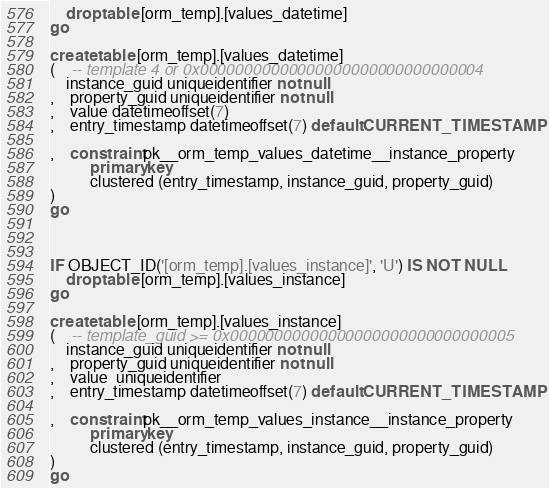Convert code to text. <code><loc_0><loc_0><loc_500><loc_500><_SQL_>	drop table [orm_temp].[values_datetime]
go

create table [orm_temp].[values_datetime]
(	-- template 4 or 0x00000000000000000000000000000004
	instance_guid uniqueidentifier not null
,	property_guid uniqueidentifier not null
,	value datetimeoffset(7)
,	entry_timestamp datetimeoffset(7) default CURRENT_TIMESTAMP

,	constraint pk__orm_temp_values_datetime__instance_property
		  primary key 
		  clustered (entry_timestamp, instance_guid, property_guid)
)
go



IF OBJECT_ID('[orm_temp].[values_instance]', 'U') IS NOT NULL
	drop table [orm_temp].[values_instance]
go

create table [orm_temp].[values_instance]
(	-- template_guid >= 0x00000000000000000000000000000005
	instance_guid uniqueidentifier not null
,	property_guid uniqueidentifier not null
,	value  uniqueidentifier
,	entry_timestamp datetimeoffset(7) default CURRENT_TIMESTAMP

,	constraint pk__orm_temp_values_instance__instance_property
		  primary key 
		  clustered (entry_timestamp, instance_guid, property_guid)
)
go



</code> 